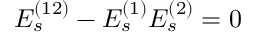<formula> <loc_0><loc_0><loc_500><loc_500>E _ { s } ^ { ( 1 2 ) } - E _ { s } ^ { ( 1 ) } E _ { s } ^ { ( 2 ) } = 0</formula> 